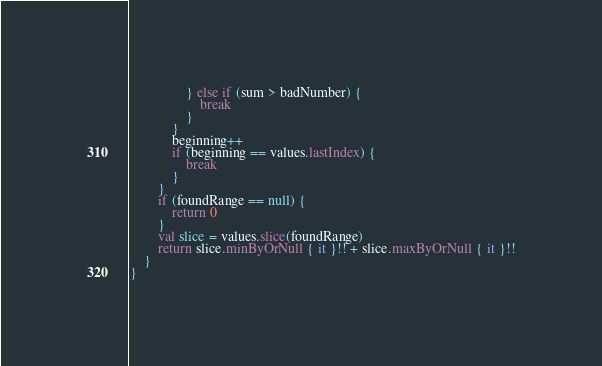Convert code to text. <code><loc_0><loc_0><loc_500><loc_500><_Kotlin_>                } else if (sum > badNumber) {
                    break
                }
            }
            beginning++
            if (beginning == values.lastIndex) {
                break
            }
        }
        if (foundRange == null) {
            return 0
        }
        val slice = values.slice(foundRange)
        return slice.minByOrNull { it }!! + slice.maxByOrNull { it }!!
    }
}</code> 